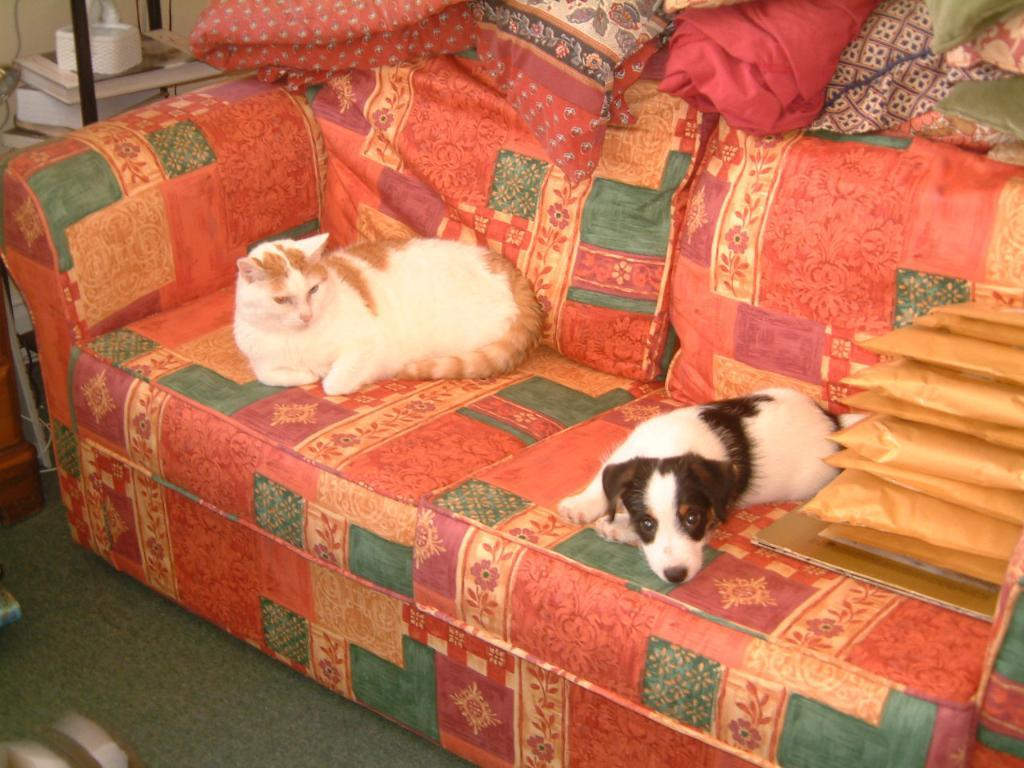What animals are present in the image? There is a cat and a dog in the image. Where are the cat and dog located in the image? Both the cat and dog are sitting on a sofa. What else can be seen in the image besides the animals? There are objects visible in the image. What part of the room can be seen in the image? The floor is visible in the bottom left corner of the image. What type of spots can be seen on the men in the image? There are no men present in the image, only a cat and a dog sitting on a sofa. How does the taste of the cat compare to the taste of the dog in the image? Cats and dogs do not have a taste, as they are animals and not food items. 